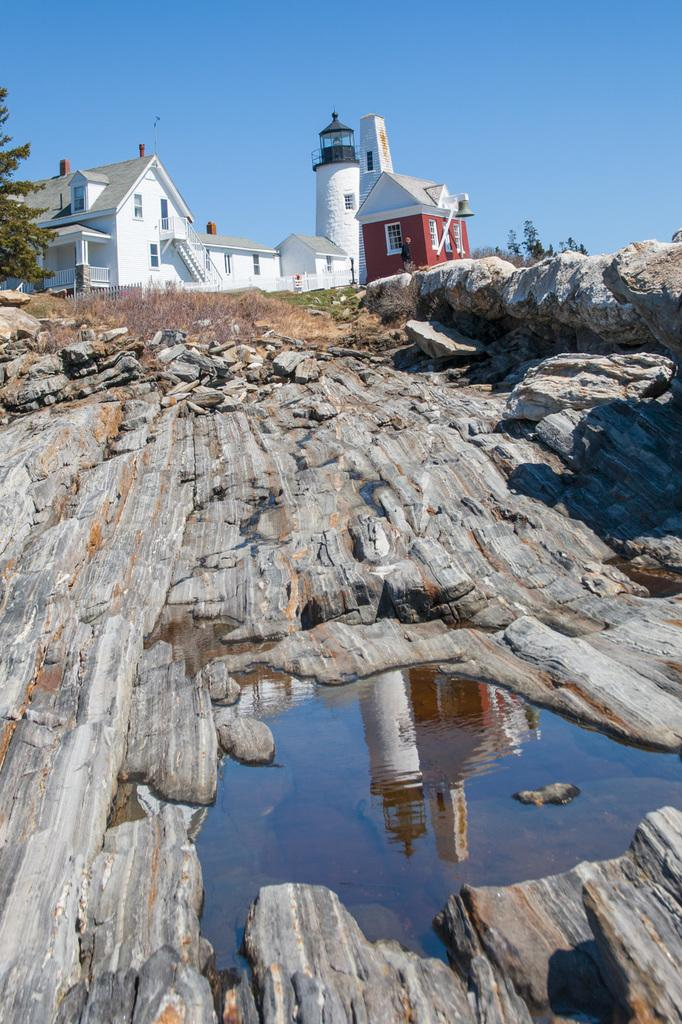What type of structure can be seen in the image? There is a building and a house in the image. What natural elements are present in the image? There are trees and rocks visible in the image. What is the condition of the water in the image? The water is visible in the image. Can you describe the reflection in the water? The building's reflection is visible in the water. What is the color of the sky in the image? The sky is blue in the image. What type of bucket is being used by the dad in the image? There is no dad or bucket present in the image. What is the belief system of the people in the image? There is no information about the belief system of the people in the image. 